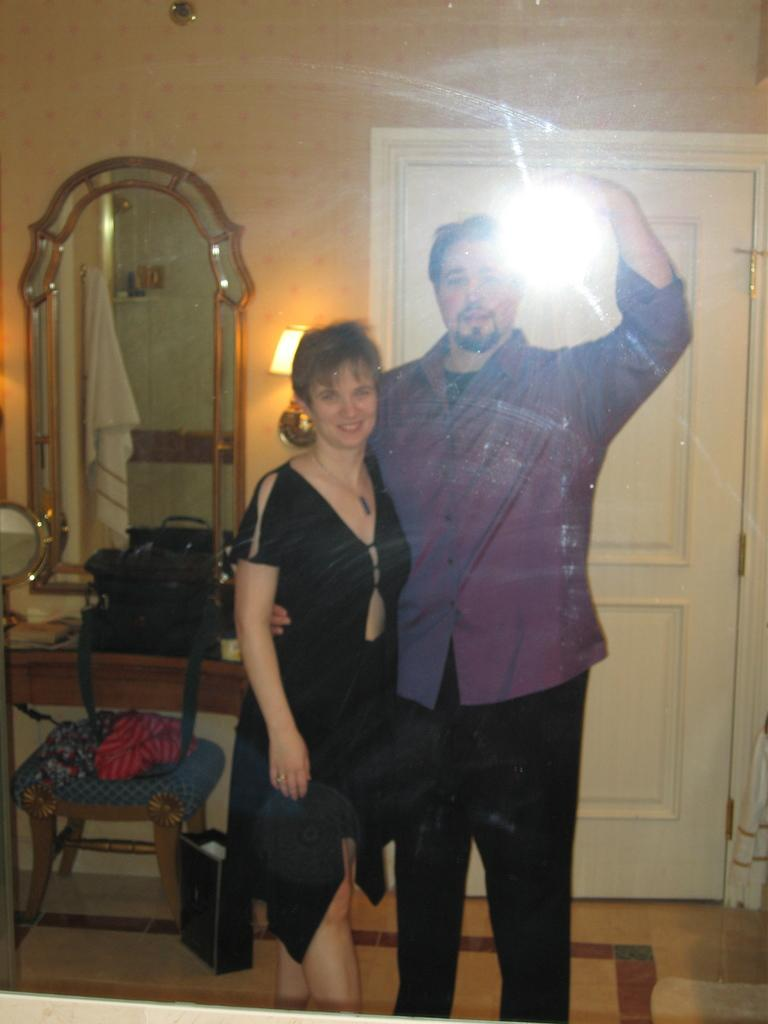How many people are in the image? There are two people in the image, a man and a woman. What are the man and woman doing in the image? Both the man and woman are on the floor. What can be seen in the background of the image? There is a dressing table, a wall, a door, a bag, a stool, and a mirror in the background of the image. What type of mountain can be seen in the background of the image? There are no mountains present in the image; it features a man and a woman on the floor with various objects in the background. Are there any firemen visible in the image? There are no firemen present in the image. 